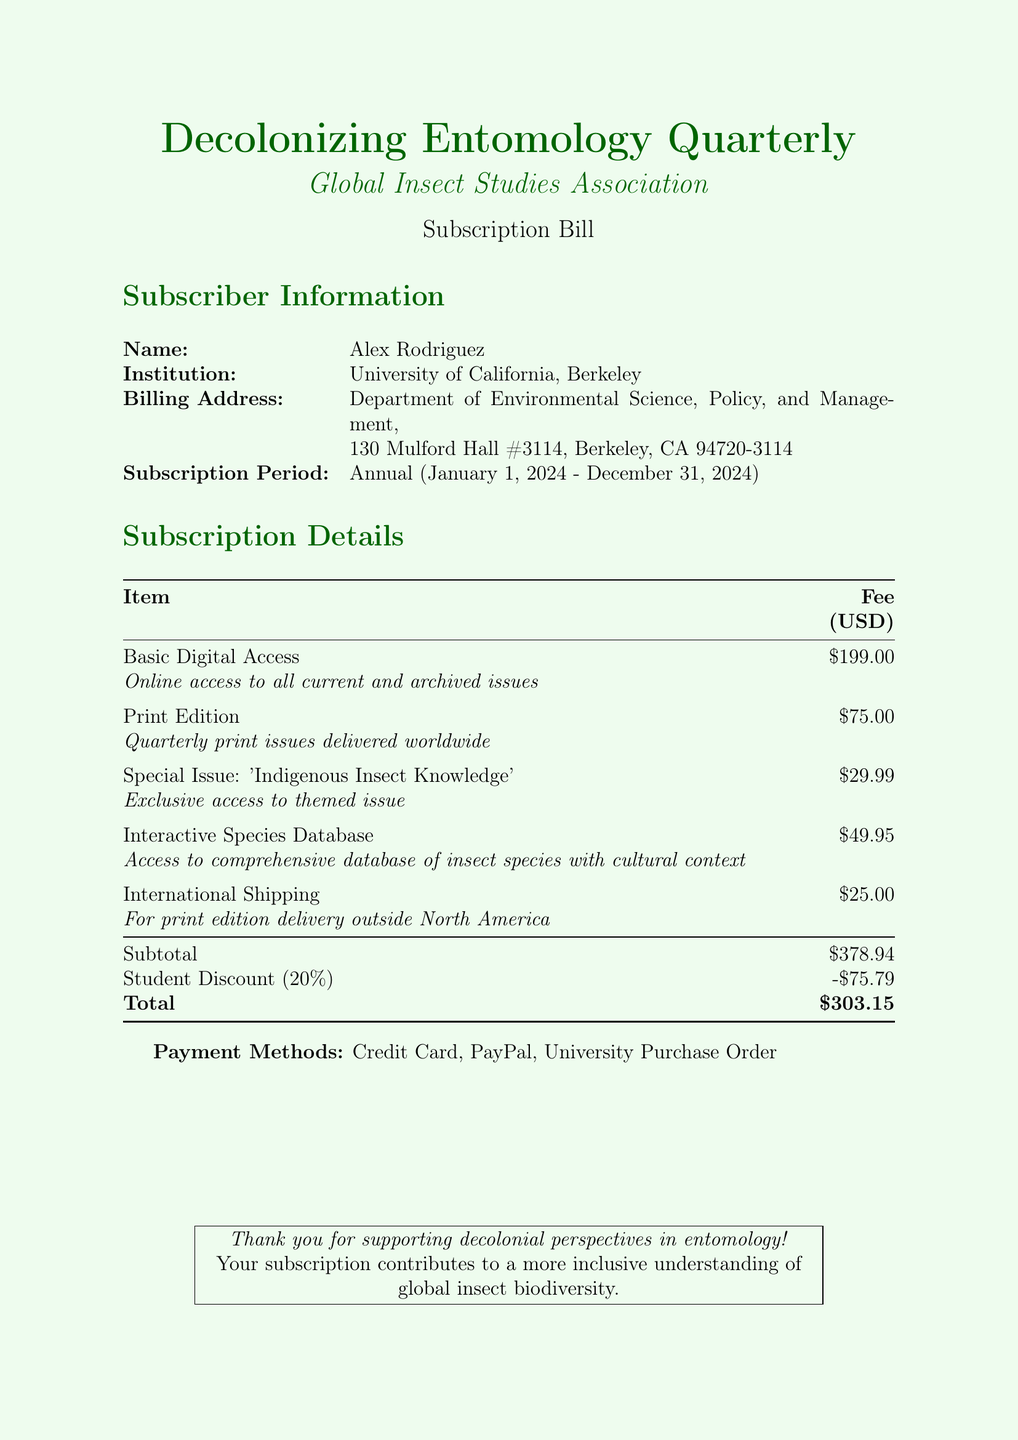What is the name of the journal? The journal is titled "Decolonizing Entomology Quarterly."
Answer: Decolonizing Entomology Quarterly What is the subscription period? The subscription period specified in the document is from January 1, 2024 to December 31, 2024.
Answer: Annual (January 1, 2024 - December 31, 2024) What is the total amount of the bill? The total amount due for the subscription, after applying the discount, is listed as $303.15.
Answer: $303.15 What is the fee for the Basic Digital Access? The Basic Digital Access fee is stated as $199.00.
Answer: $199.00 How much is the student discount? The student discount applied to the subscription bill is a reduction of $75.79.
Answer: -$75.79 Which payment methods are accepted? The document specifies three payment options: Credit Card, PayPal, and University Purchase Order.
Answer: Credit Card, PayPal, University Purchase Order What is included in the Special Issue? The Special Issue mentioned is themed 'Indigenous Insect Knowledge.'
Answer: Indigenous Insect Knowledge How much does international shipping cost? The fee for international shipping listed in the document is $25.00.
Answer: $25.00 What type of database access is provided? The document states access to an Interactive Species Database is included.
Answer: Interactive Species Database 